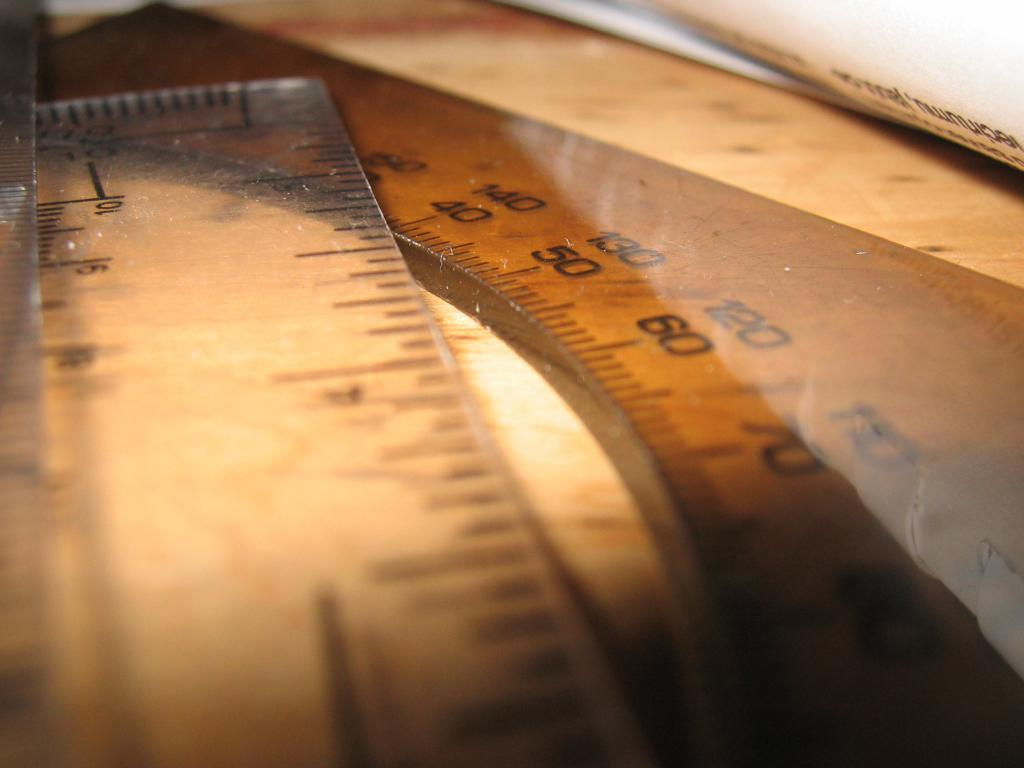<image>
Summarize the visual content of the image. A plastic ruler and a protractor with numbers such as 40 and 50 on lay on a wooden table. 